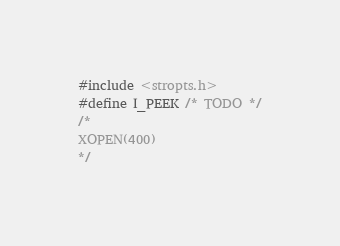Convert code to text. <code><loc_0><loc_0><loc_500><loc_500><_C_>#include <stropts.h>
#define I_PEEK /* TODO */
/*
XOPEN(400)
*/</code> 